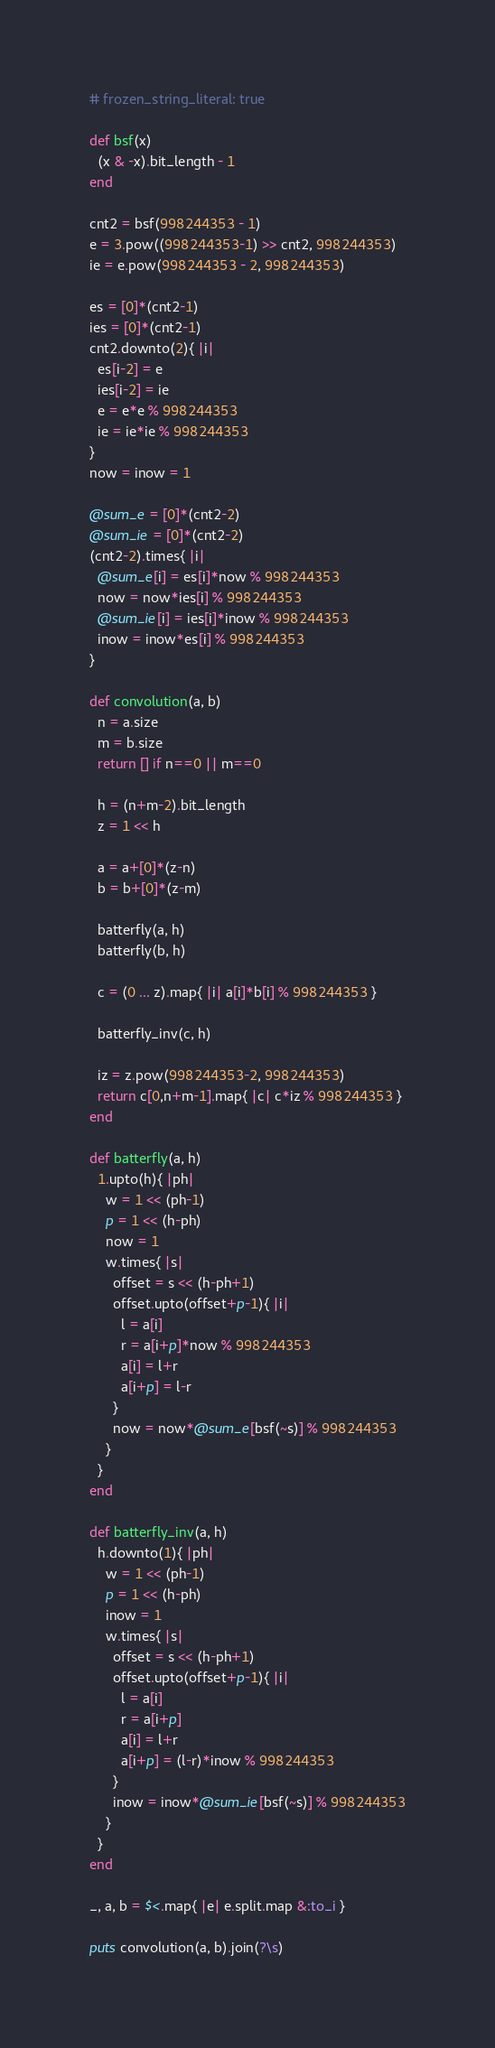<code> <loc_0><loc_0><loc_500><loc_500><_Ruby_># frozen_string_literal: true

def bsf(x)
  (x & -x).bit_length - 1
end

cnt2 = bsf(998244353 - 1)
e = 3.pow((998244353-1) >> cnt2, 998244353)
ie = e.pow(998244353 - 2, 998244353)

es = [0]*(cnt2-1)
ies = [0]*(cnt2-1)
cnt2.downto(2){ |i|
  es[i-2] = e
  ies[i-2] = ie
  e = e*e % 998244353
  ie = ie*ie % 998244353
}
now = inow = 1

@sum_e = [0]*(cnt2-2)
@sum_ie = [0]*(cnt2-2)
(cnt2-2).times{ |i|
  @sum_e[i] = es[i]*now % 998244353
  now = now*ies[i] % 998244353
  @sum_ie[i] = ies[i]*inow % 998244353
  inow = inow*es[i] % 998244353
}

def convolution(a, b)
  n = a.size
  m = b.size
  return [] if n==0 || m==0

  h = (n+m-2).bit_length
  z = 1 << h

  a = a+[0]*(z-n)
  b = b+[0]*(z-m)

  batterfly(a, h)
  batterfly(b, h)

  c = (0 ... z).map{ |i| a[i]*b[i] % 998244353 }

  batterfly_inv(c, h)

  iz = z.pow(998244353-2, 998244353)
  return c[0,n+m-1].map{ |c| c*iz % 998244353 }
end

def batterfly(a, h)
  1.upto(h){ |ph|
    w = 1 << (ph-1)
    p = 1 << (h-ph)
    now = 1
    w.times{ |s|
      offset = s << (h-ph+1)
      offset.upto(offset+p-1){ |i|
        l = a[i]
        r = a[i+p]*now % 998244353
        a[i] = l+r
        a[i+p] = l-r
      }
      now = now*@sum_e[bsf(~s)] % 998244353
    }
  }
end

def batterfly_inv(a, h)
  h.downto(1){ |ph|
    w = 1 << (ph-1)
    p = 1 << (h-ph)
    inow = 1
    w.times{ |s|
      offset = s << (h-ph+1)
      offset.upto(offset+p-1){ |i|
        l = a[i]
        r = a[i+p]
        a[i] = l+r
        a[i+p] = (l-r)*inow % 998244353
      }
      inow = inow*@sum_ie[bsf(~s)] % 998244353
    }
  }
end

_, a, b = $<.map{ |e| e.split.map &:to_i }

puts convolution(a, b).join(?\s)
</code> 